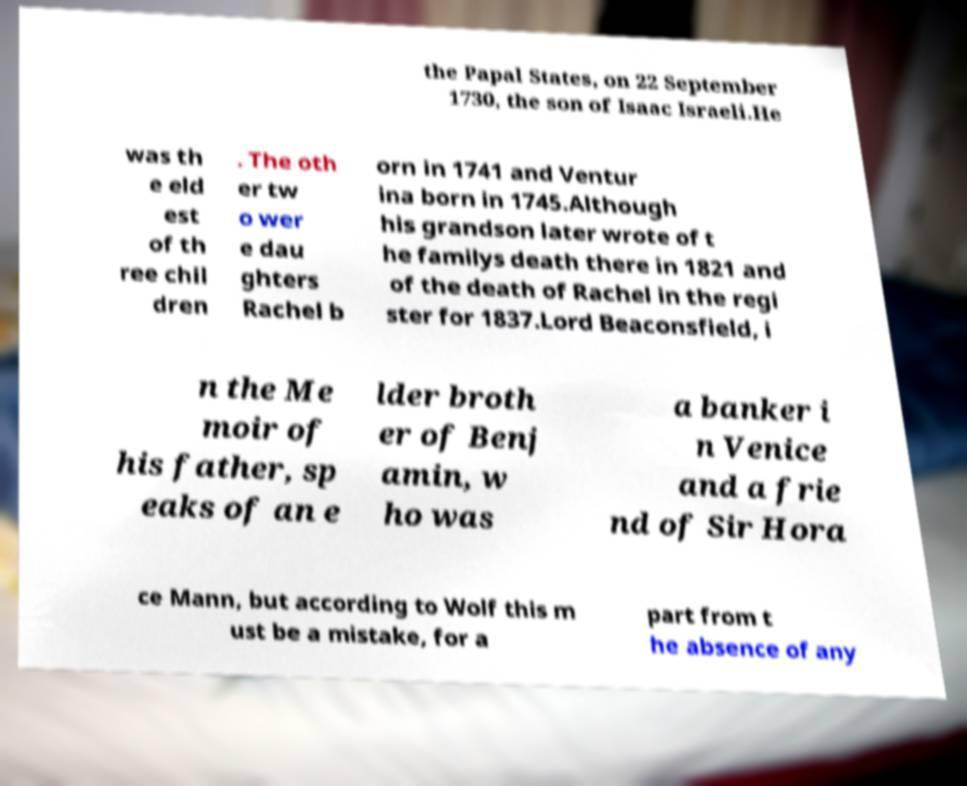Can you read and provide the text displayed in the image?This photo seems to have some interesting text. Can you extract and type it out for me? the Papal States, on 22 September 1730, the son of Isaac Israeli.He was th e eld est of th ree chil dren . The oth er tw o wer e dau ghters Rachel b orn in 1741 and Ventur ina born in 1745.Although his grandson later wrote of t he familys death there in 1821 and of the death of Rachel in the regi ster for 1837.Lord Beaconsfield, i n the Me moir of his father, sp eaks of an e lder broth er of Benj amin, w ho was a banker i n Venice and a frie nd of Sir Hora ce Mann, but according to Wolf this m ust be a mistake, for a part from t he absence of any 